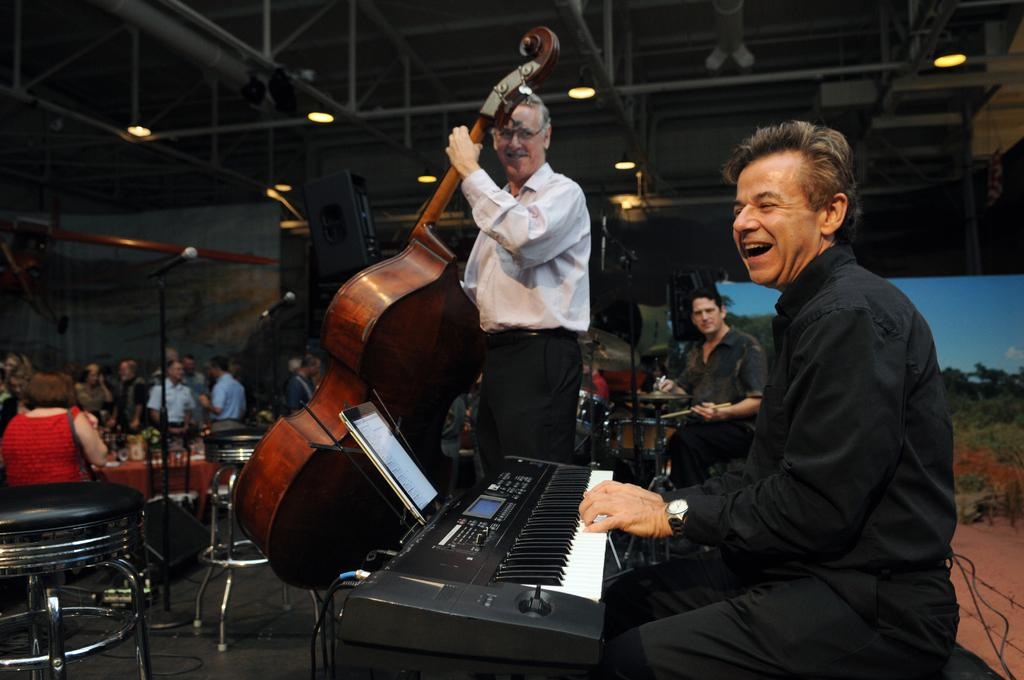What is the man in the image doing? The man is wearing costumes and playing the piano. What is another man in the image playing? There is a man playing a big violin. What instrument is the third man playing? The third man is playing drums. Can you describe the setting where these musicians are performing? There is a group of people in the hall where the musicians are playing. What type of scent can be smelled in the image? There is no mention of a scent in the image, so it cannot be determined from the image. 